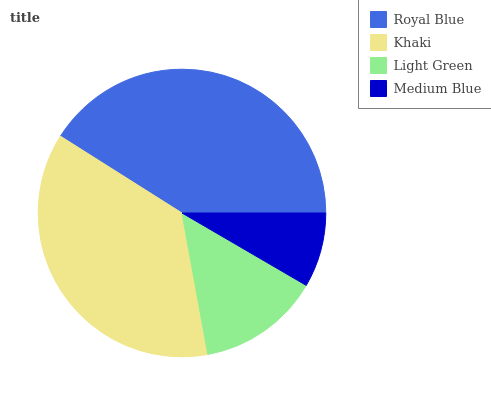Is Medium Blue the minimum?
Answer yes or no. Yes. Is Royal Blue the maximum?
Answer yes or no. Yes. Is Khaki the minimum?
Answer yes or no. No. Is Khaki the maximum?
Answer yes or no. No. Is Royal Blue greater than Khaki?
Answer yes or no. Yes. Is Khaki less than Royal Blue?
Answer yes or no. Yes. Is Khaki greater than Royal Blue?
Answer yes or no. No. Is Royal Blue less than Khaki?
Answer yes or no. No. Is Khaki the high median?
Answer yes or no. Yes. Is Light Green the low median?
Answer yes or no. Yes. Is Light Green the high median?
Answer yes or no. No. Is Royal Blue the low median?
Answer yes or no. No. 